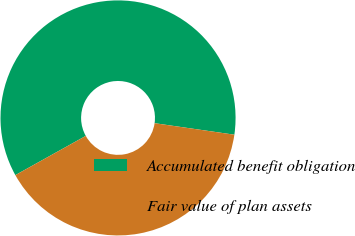Convert chart. <chart><loc_0><loc_0><loc_500><loc_500><pie_chart><fcel>Accumulated benefit obligation<fcel>Fair value of plan assets<nl><fcel>60.37%<fcel>39.63%<nl></chart> 